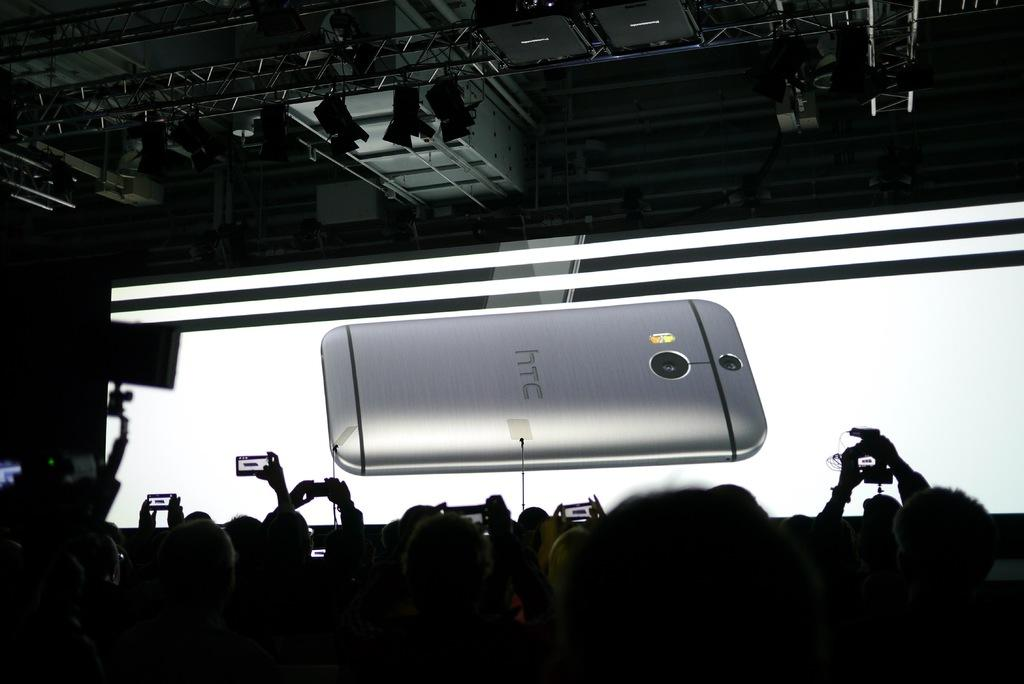Provide a one-sentence caption for the provided image. A smartphone from HTC is placed on a brightly lit desk face down. 